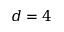<formula> <loc_0><loc_0><loc_500><loc_500>d = 4</formula> 